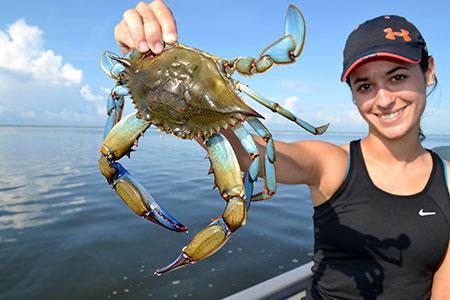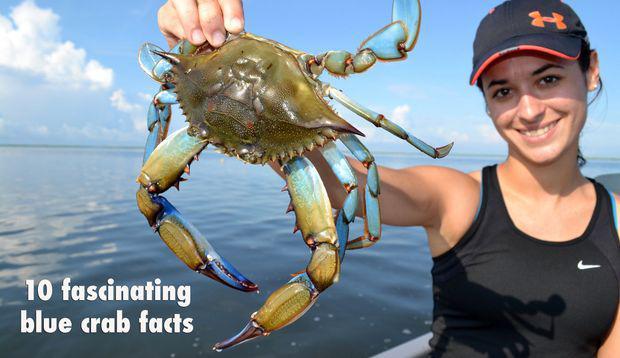The first image is the image on the left, the second image is the image on the right. For the images displayed, is the sentence "There are crabs inside a cage." factually correct? Answer yes or no. No. The first image is the image on the left, the second image is the image on the right. For the images shown, is this caption "In at least one image there is a round crab trap that is holding at least 15 crab while being held by a person in a boat." true? Answer yes or no. No. 